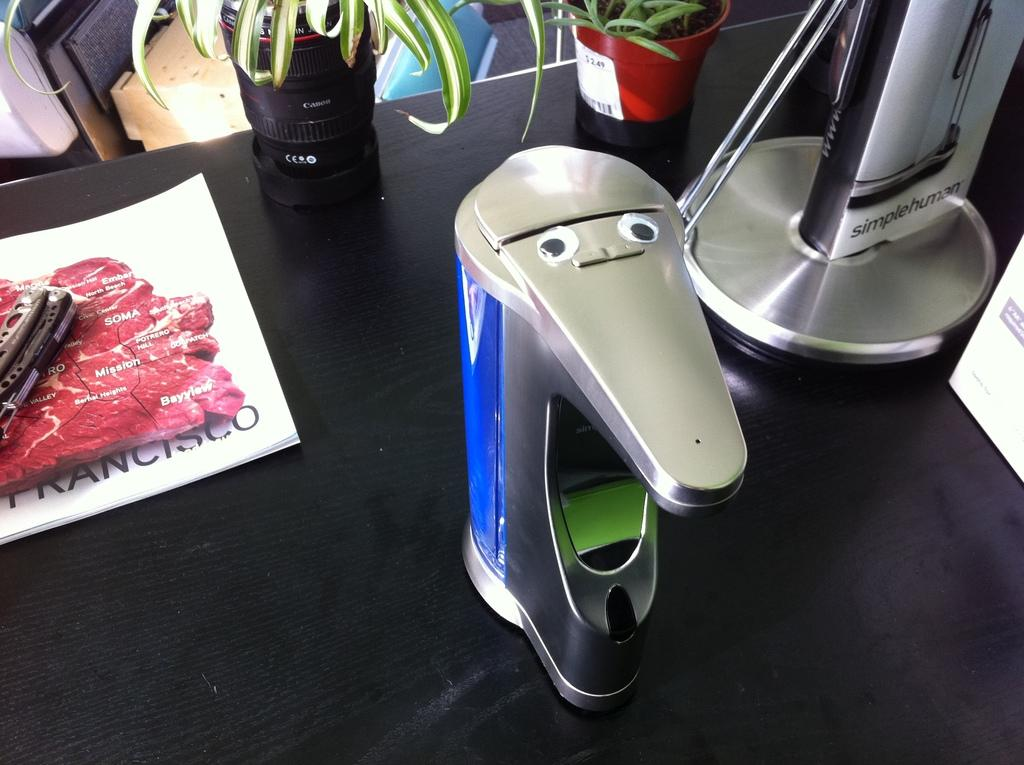<image>
Provide a brief description of the given image. A collection of objects are on a desk, including a plant that cost $2.49. 